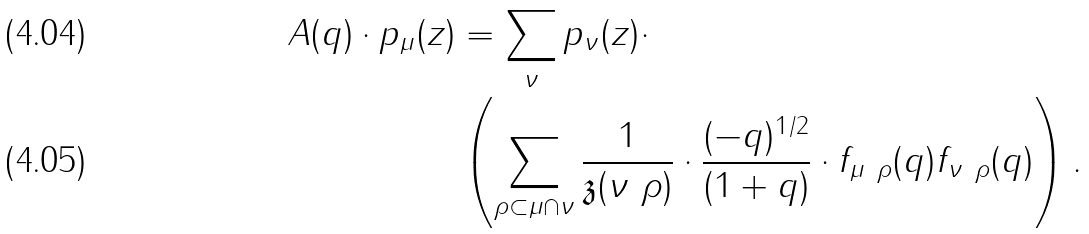Convert formula to latex. <formula><loc_0><loc_0><loc_500><loc_500>A ( q ) \cdot p _ { \mu } ( z ) & = \sum _ { \nu } p _ { \nu } ( z ) \cdot \\ & \left ( \sum _ { \rho \subset \mu \cap \nu } \frac { 1 } { \mathfrak { z } ( \nu \ \rho ) } \cdot \frac { ( - q ) ^ { 1 / 2 } } { ( 1 + q ) } \cdot f _ { \mu \ \rho } ( q ) f _ { \nu \ \rho } ( q ) \right ) .</formula> 